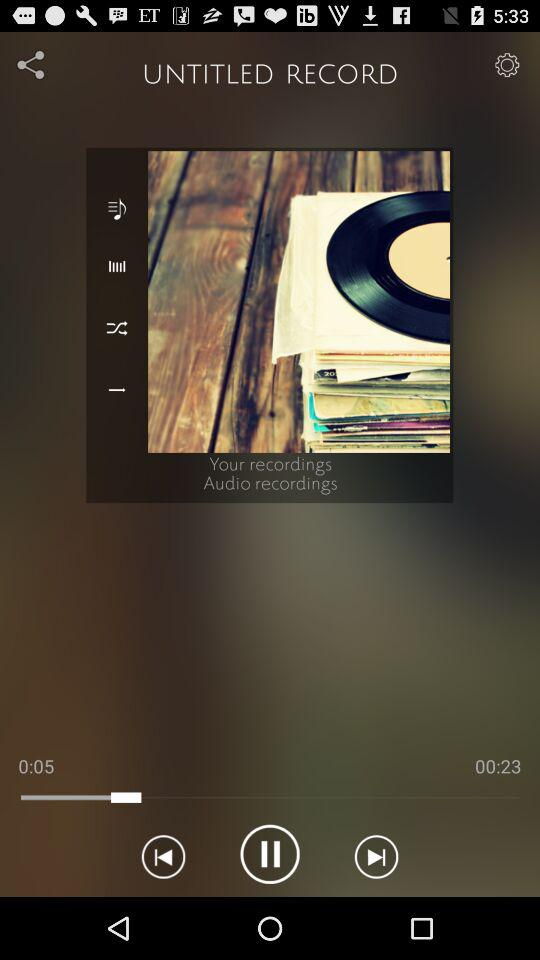What is the album name? The album name is "UNTITLED RECORD". 